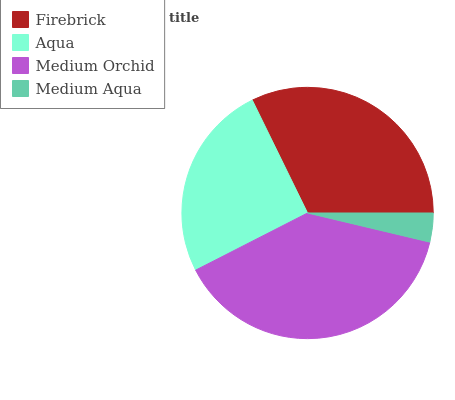Is Medium Aqua the minimum?
Answer yes or no. Yes. Is Medium Orchid the maximum?
Answer yes or no. Yes. Is Aqua the minimum?
Answer yes or no. No. Is Aqua the maximum?
Answer yes or no. No. Is Firebrick greater than Aqua?
Answer yes or no. Yes. Is Aqua less than Firebrick?
Answer yes or no. Yes. Is Aqua greater than Firebrick?
Answer yes or no. No. Is Firebrick less than Aqua?
Answer yes or no. No. Is Firebrick the high median?
Answer yes or no. Yes. Is Aqua the low median?
Answer yes or no. Yes. Is Medium Orchid the high median?
Answer yes or no. No. Is Medium Orchid the low median?
Answer yes or no. No. 